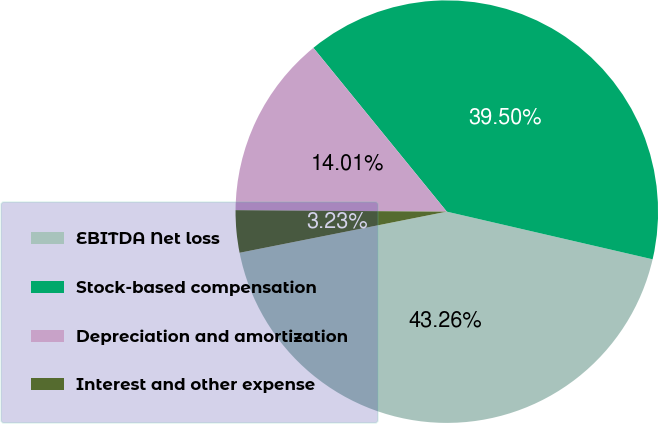<chart> <loc_0><loc_0><loc_500><loc_500><pie_chart><fcel>EBITDA Net loss<fcel>Stock-based compensation<fcel>Depreciation and amortization<fcel>Interest and other expense<nl><fcel>43.26%<fcel>39.5%<fcel>14.01%<fcel>3.23%<nl></chart> 